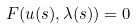Convert formula to latex. <formula><loc_0><loc_0><loc_500><loc_500>F ( u ( s ) , \lambda ( s ) ) = 0</formula> 